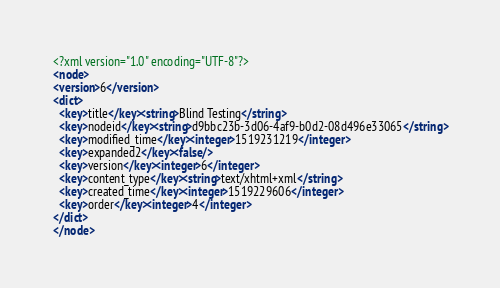Convert code to text. <code><loc_0><loc_0><loc_500><loc_500><_XML_><?xml version="1.0" encoding="UTF-8"?>
<node>
<version>6</version>
<dict>
  <key>title</key><string>Blind Testing</string>
  <key>nodeid</key><string>d9bbc23b-3d06-4af9-b0d2-08d496e33065</string>
  <key>modified_time</key><integer>1519231219</integer>
  <key>expanded2</key><false/>
  <key>version</key><integer>6</integer>
  <key>content_type</key><string>text/xhtml+xml</string>
  <key>created_time</key><integer>1519229606</integer>
  <key>order</key><integer>4</integer>
</dict>
</node>
</code> 